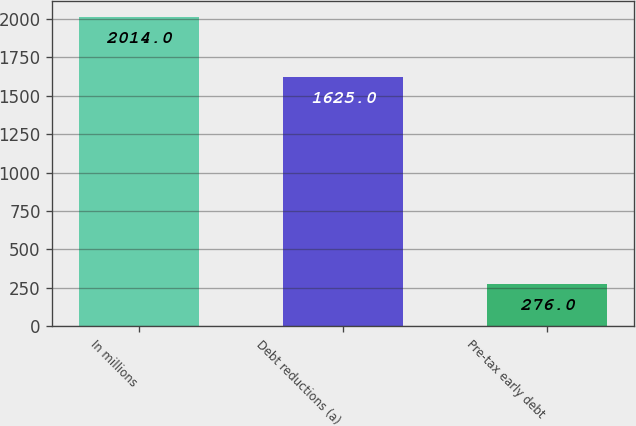Convert chart. <chart><loc_0><loc_0><loc_500><loc_500><bar_chart><fcel>In millions<fcel>Debt reductions (a)<fcel>Pre-tax early debt<nl><fcel>2014<fcel>1625<fcel>276<nl></chart> 